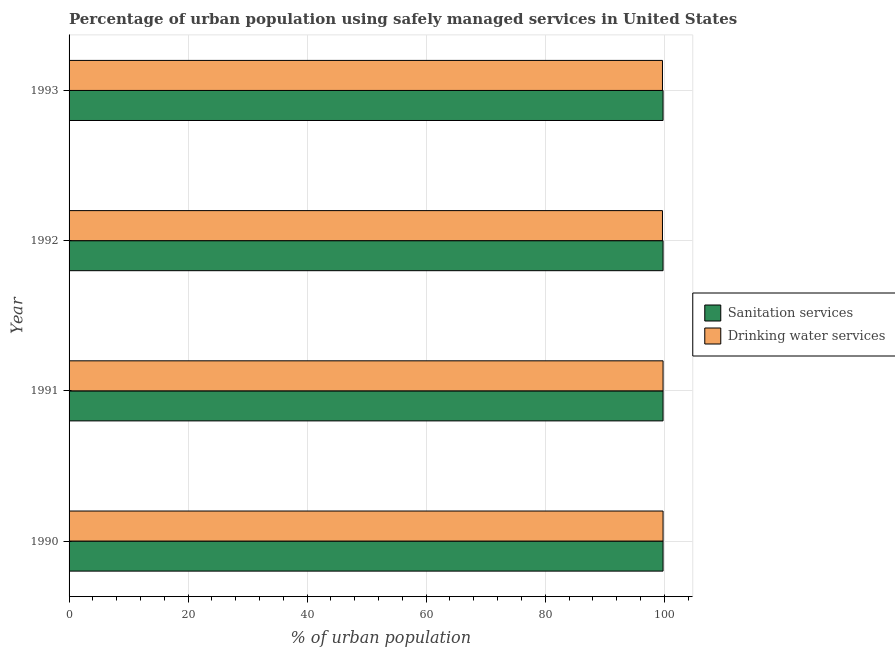How many different coloured bars are there?
Provide a succinct answer. 2. How many bars are there on the 3rd tick from the top?
Your answer should be compact. 2. How many bars are there on the 3rd tick from the bottom?
Give a very brief answer. 2. What is the percentage of urban population who used sanitation services in 1990?
Your response must be concise. 99.8. Across all years, what is the maximum percentage of urban population who used drinking water services?
Your response must be concise. 99.8. Across all years, what is the minimum percentage of urban population who used drinking water services?
Give a very brief answer. 99.7. What is the total percentage of urban population who used drinking water services in the graph?
Your answer should be compact. 399. What is the difference between the percentage of urban population who used sanitation services in 1991 and that in 1992?
Provide a short and direct response. 0. What is the difference between the percentage of urban population who used sanitation services in 1992 and the percentage of urban population who used drinking water services in 1990?
Offer a terse response. 0. What is the average percentage of urban population who used drinking water services per year?
Your response must be concise. 99.75. In the year 1992, what is the difference between the percentage of urban population who used sanitation services and percentage of urban population who used drinking water services?
Provide a succinct answer. 0.1. What is the ratio of the percentage of urban population who used sanitation services in 1990 to that in 1991?
Provide a succinct answer. 1. Is the percentage of urban population who used sanitation services in 1990 less than that in 1993?
Offer a terse response. No. What is the difference between the highest and the second highest percentage of urban population who used sanitation services?
Provide a succinct answer. 0. What is the difference between the highest and the lowest percentage of urban population who used sanitation services?
Ensure brevity in your answer.  0. What does the 2nd bar from the top in 1991 represents?
Your answer should be very brief. Sanitation services. What does the 2nd bar from the bottom in 1992 represents?
Provide a short and direct response. Drinking water services. How many years are there in the graph?
Offer a terse response. 4. What is the difference between two consecutive major ticks on the X-axis?
Provide a succinct answer. 20. Does the graph contain any zero values?
Offer a very short reply. No. How many legend labels are there?
Offer a terse response. 2. What is the title of the graph?
Your response must be concise. Percentage of urban population using safely managed services in United States. Does "Education" appear as one of the legend labels in the graph?
Provide a short and direct response. No. What is the label or title of the X-axis?
Provide a succinct answer. % of urban population. What is the label or title of the Y-axis?
Offer a terse response. Year. What is the % of urban population of Sanitation services in 1990?
Your answer should be very brief. 99.8. What is the % of urban population in Drinking water services in 1990?
Provide a short and direct response. 99.8. What is the % of urban population in Sanitation services in 1991?
Offer a terse response. 99.8. What is the % of urban population of Drinking water services in 1991?
Your answer should be compact. 99.8. What is the % of urban population of Sanitation services in 1992?
Offer a terse response. 99.8. What is the % of urban population in Drinking water services in 1992?
Keep it short and to the point. 99.7. What is the % of urban population of Sanitation services in 1993?
Keep it short and to the point. 99.8. What is the % of urban population in Drinking water services in 1993?
Offer a very short reply. 99.7. Across all years, what is the maximum % of urban population of Sanitation services?
Your response must be concise. 99.8. Across all years, what is the maximum % of urban population in Drinking water services?
Your response must be concise. 99.8. Across all years, what is the minimum % of urban population in Sanitation services?
Offer a terse response. 99.8. Across all years, what is the minimum % of urban population of Drinking water services?
Give a very brief answer. 99.7. What is the total % of urban population in Sanitation services in the graph?
Make the answer very short. 399.2. What is the total % of urban population of Drinking water services in the graph?
Provide a short and direct response. 399. What is the difference between the % of urban population of Sanitation services in 1990 and that in 1991?
Keep it short and to the point. 0. What is the difference between the % of urban population of Sanitation services in 1990 and that in 1992?
Provide a short and direct response. 0. What is the difference between the % of urban population in Sanitation services in 1990 and that in 1993?
Offer a very short reply. 0. What is the difference between the % of urban population of Sanitation services in 1991 and that in 1992?
Provide a succinct answer. 0. What is the difference between the % of urban population of Drinking water services in 1991 and that in 1992?
Give a very brief answer. 0.1. What is the difference between the % of urban population in Drinking water services in 1991 and that in 1993?
Offer a very short reply. 0.1. What is the difference between the % of urban population of Sanitation services in 1990 and the % of urban population of Drinking water services in 1992?
Ensure brevity in your answer.  0.1. What is the difference between the % of urban population of Sanitation services in 1992 and the % of urban population of Drinking water services in 1993?
Your answer should be compact. 0.1. What is the average % of urban population in Sanitation services per year?
Offer a very short reply. 99.8. What is the average % of urban population of Drinking water services per year?
Your answer should be very brief. 99.75. In the year 1991, what is the difference between the % of urban population of Sanitation services and % of urban population of Drinking water services?
Offer a terse response. 0. In the year 1992, what is the difference between the % of urban population in Sanitation services and % of urban population in Drinking water services?
Provide a short and direct response. 0.1. In the year 1993, what is the difference between the % of urban population in Sanitation services and % of urban population in Drinking water services?
Give a very brief answer. 0.1. What is the ratio of the % of urban population in Drinking water services in 1990 to that in 1991?
Keep it short and to the point. 1. What is the ratio of the % of urban population of Sanitation services in 1990 to that in 1992?
Provide a succinct answer. 1. What is the ratio of the % of urban population of Sanitation services in 1990 to that in 1993?
Your answer should be compact. 1. What is the ratio of the % of urban population of Sanitation services in 1991 to that in 1992?
Provide a short and direct response. 1. What is the ratio of the % of urban population of Sanitation services in 1992 to that in 1993?
Your answer should be very brief. 1. What is the ratio of the % of urban population in Drinking water services in 1992 to that in 1993?
Ensure brevity in your answer.  1. What is the difference between the highest and the second highest % of urban population of Drinking water services?
Keep it short and to the point. 0. 